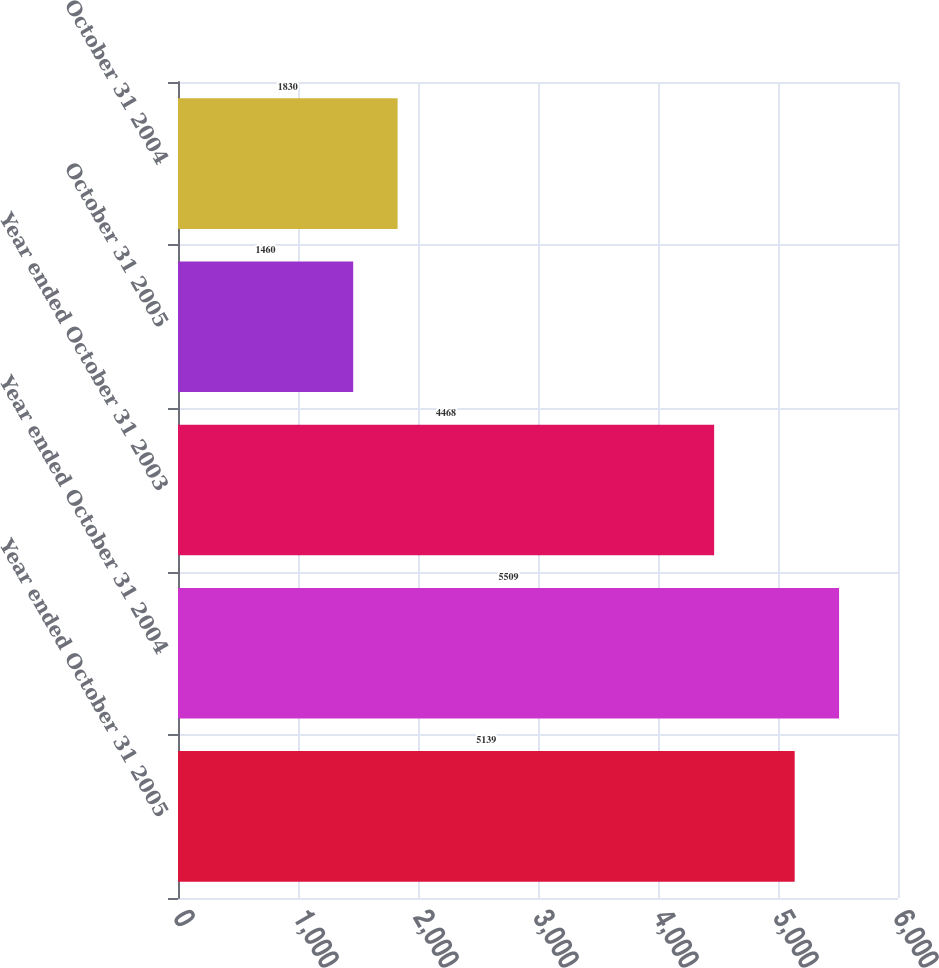Convert chart. <chart><loc_0><loc_0><loc_500><loc_500><bar_chart><fcel>Year ended October 31 2005<fcel>Year ended October 31 2004<fcel>Year ended October 31 2003<fcel>October 31 2005<fcel>October 31 2004<nl><fcel>5139<fcel>5509<fcel>4468<fcel>1460<fcel>1830<nl></chart> 